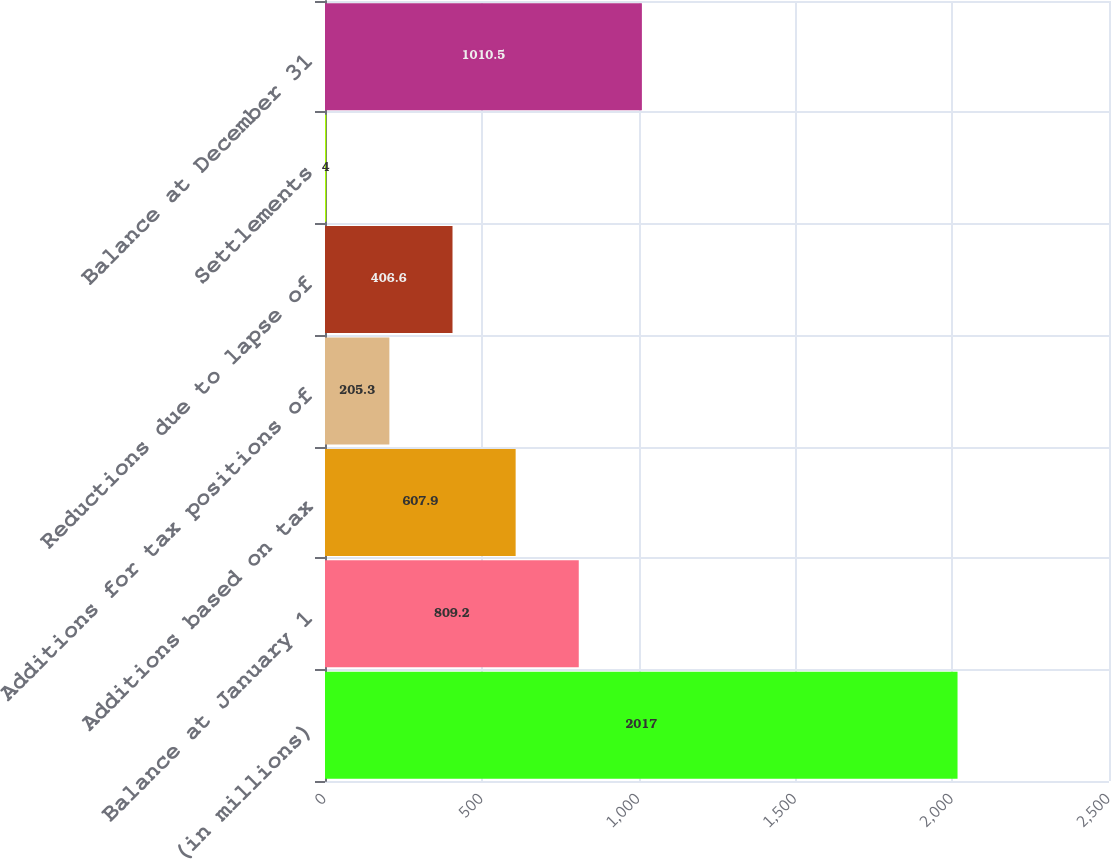Convert chart. <chart><loc_0><loc_0><loc_500><loc_500><bar_chart><fcel>(in millions)<fcel>Balance at January 1<fcel>Additions based on tax<fcel>Additions for tax positions of<fcel>Reductions due to lapse of<fcel>Settlements<fcel>Balance at December 31<nl><fcel>2017<fcel>809.2<fcel>607.9<fcel>205.3<fcel>406.6<fcel>4<fcel>1010.5<nl></chart> 